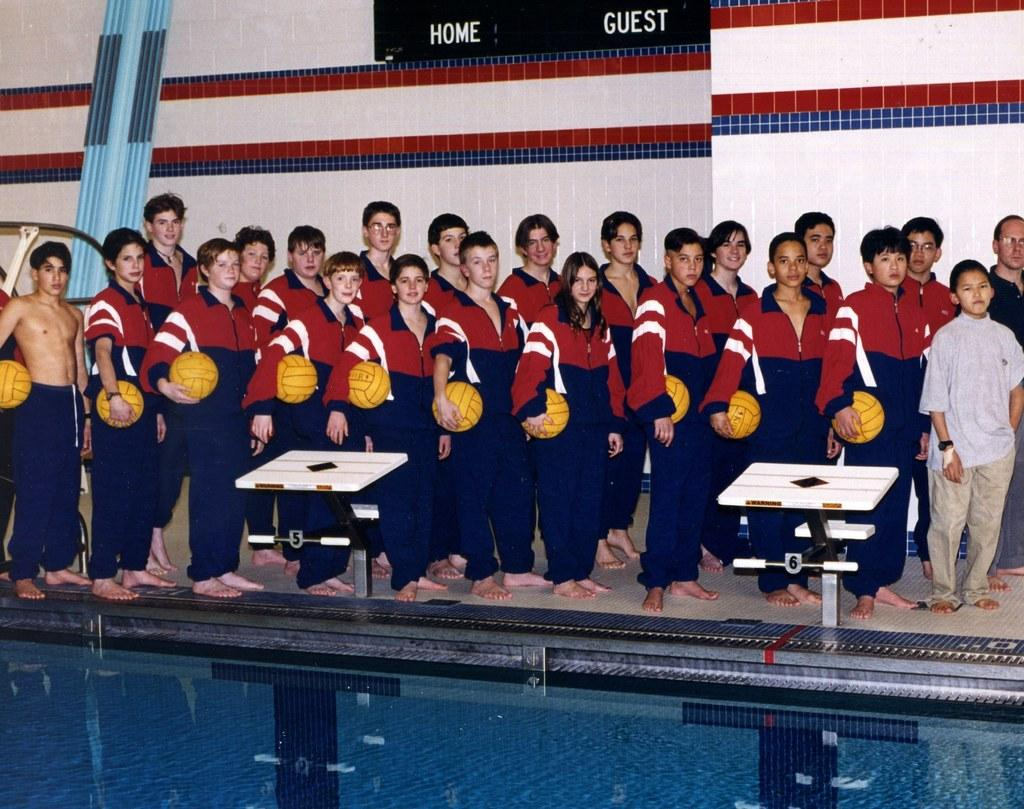How many people are in the image? There are many people in the image. What are the people doing in the image? The people are standing together beside a swimming pool. What objects are some people holding in the image? Some people are holding balls in the image. What can be seen in the background of the image? There is a wall visible in the background of the image. What type of current can be felt in the swimming pool in the image? There is no information about the swimming pool's current in the image. What scent is present in the image? There is no information about any scent in the image. 